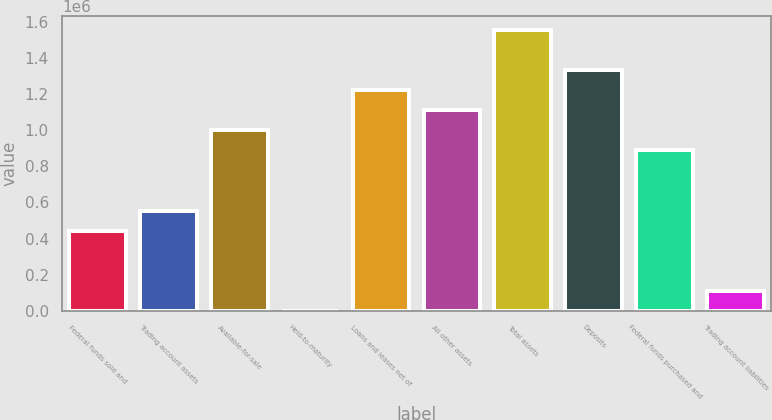<chart> <loc_0><loc_0><loc_500><loc_500><bar_chart><fcel>Federal funds sold and<fcel>Trading account assets<fcel>Available-for-sale<fcel>Held-to-maturity<fcel>Loans and leases net of<fcel>All other assets<fcel>Total assets<fcel>Deposits<fcel>Federal funds purchased and<fcel>Trading account liabilities<nl><fcel>444371<fcel>555381<fcel>999422<fcel>330<fcel>1.22144e+06<fcel>1.11043e+06<fcel>1.55447e+06<fcel>1.33245e+06<fcel>888412<fcel>111340<nl></chart> 